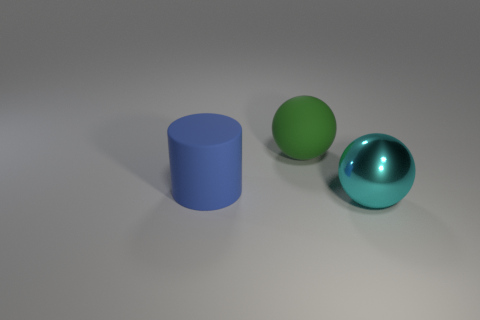Add 3 blue blocks. How many objects exist? 6 Subtract all balls. How many objects are left? 1 Add 1 big cylinders. How many big cylinders are left? 2 Add 1 big objects. How many big objects exist? 4 Subtract 1 cyan balls. How many objects are left? 2 Subtract all small yellow blocks. Subtract all green objects. How many objects are left? 2 